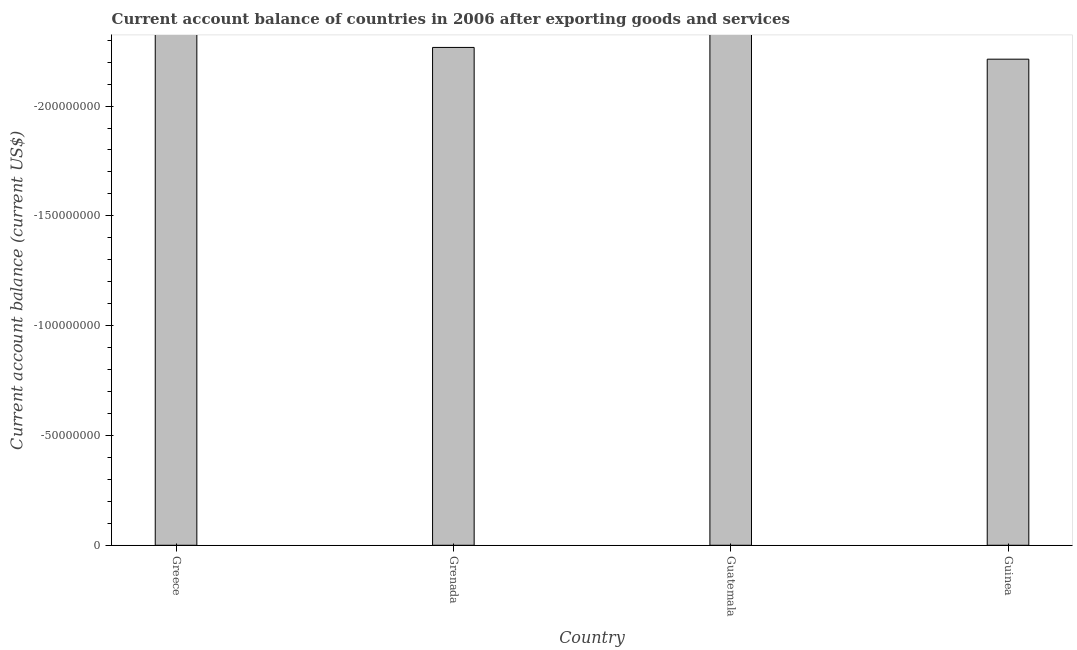What is the title of the graph?
Give a very brief answer. Current account balance of countries in 2006 after exporting goods and services. What is the label or title of the X-axis?
Offer a very short reply. Country. What is the label or title of the Y-axis?
Your answer should be very brief. Current account balance (current US$). What is the sum of the current account balance?
Give a very brief answer. 0. What is the median current account balance?
Your response must be concise. 0. In how many countries, is the current account balance greater than the average current account balance taken over all countries?
Ensure brevity in your answer.  0. How many bars are there?
Provide a short and direct response. 0. Are all the bars in the graph horizontal?
Your response must be concise. No. How many countries are there in the graph?
Offer a terse response. 4. What is the Current account balance (current US$) in Greece?
Offer a very short reply. 0. 